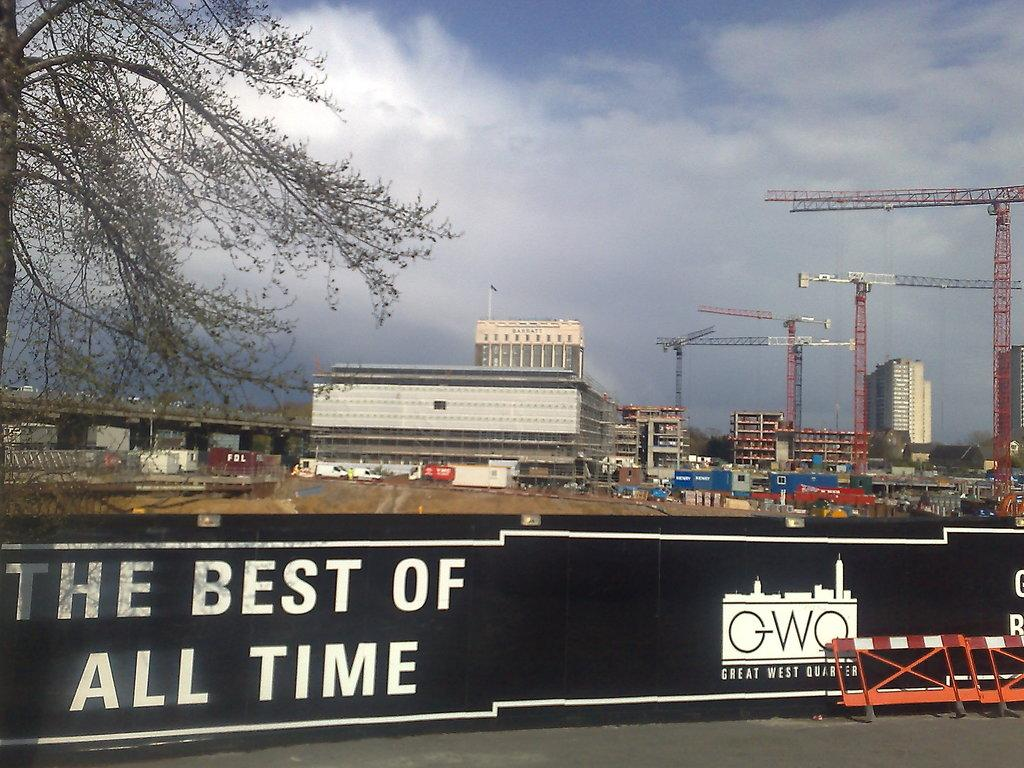<image>
Offer a succinct explanation of the picture presented. A fence bearing the words the best of all time separates people from a huge construction site. 